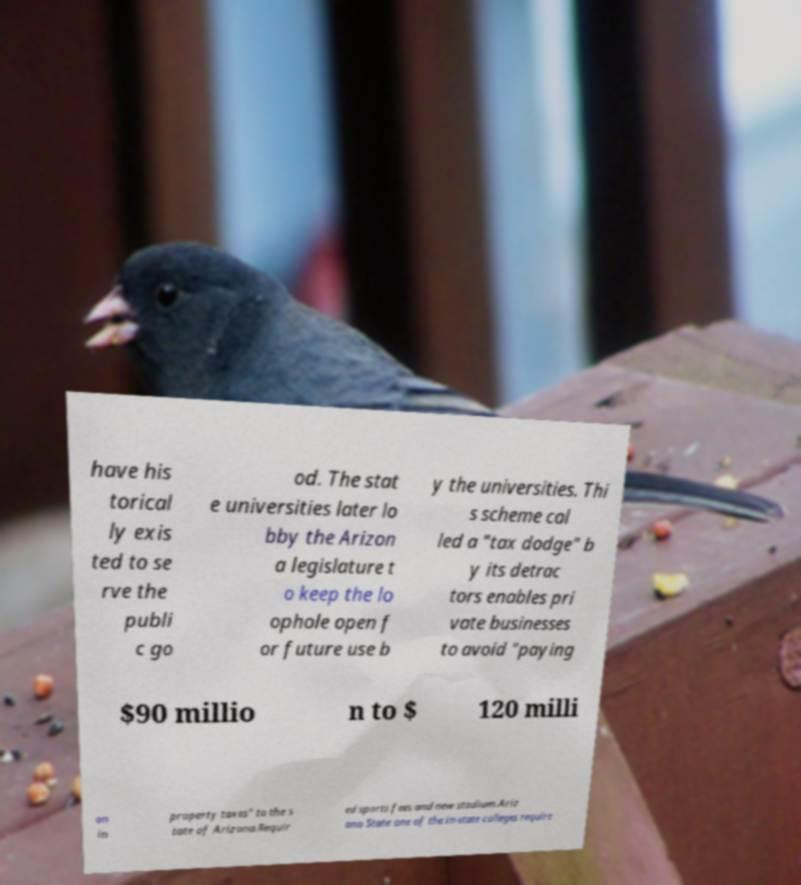Could you assist in decoding the text presented in this image and type it out clearly? have his torical ly exis ted to se rve the publi c go od. The stat e universities later lo bby the Arizon a legislature t o keep the lo ophole open f or future use b y the universities. Thi s scheme cal led a "tax dodge" b y its detrac tors enables pri vate businesses to avoid "paying $90 millio n to $ 120 milli on in property taxes" to the s tate of Arizona.Requir ed sports fees and new stadium.Ariz ona State one of the in-state colleges require 